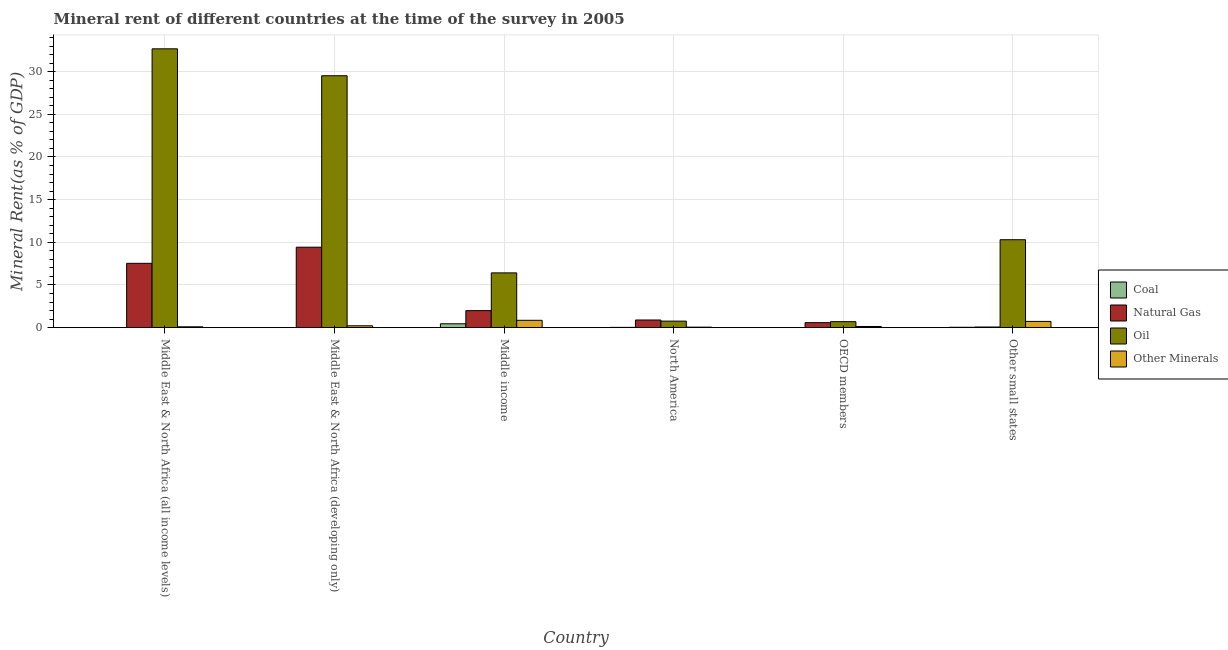How many different coloured bars are there?
Keep it short and to the point. 4. How many groups of bars are there?
Provide a succinct answer. 6. Are the number of bars per tick equal to the number of legend labels?
Offer a very short reply. Yes. Are the number of bars on each tick of the X-axis equal?
Offer a terse response. Yes. How many bars are there on the 6th tick from the left?
Provide a short and direct response. 4. What is the label of the 2nd group of bars from the left?
Provide a succinct answer. Middle East & North Africa (developing only). In how many cases, is the number of bars for a given country not equal to the number of legend labels?
Give a very brief answer. 0. What is the oil rent in Other small states?
Your response must be concise. 10.3. Across all countries, what is the maximum natural gas rent?
Your response must be concise. 9.43. Across all countries, what is the minimum coal rent?
Ensure brevity in your answer.  0. In which country was the natural gas rent maximum?
Make the answer very short. Middle East & North Africa (developing only). In which country was the natural gas rent minimum?
Give a very brief answer. Other small states. What is the total natural gas rent in the graph?
Your response must be concise. 20.53. What is the difference between the  rent of other minerals in Middle income and that in North America?
Provide a succinct answer. 0.8. What is the difference between the coal rent in Middle income and the natural gas rent in North America?
Give a very brief answer. -0.44. What is the average  rent of other minerals per country?
Your response must be concise. 0.35. What is the difference between the  rent of other minerals and coal rent in North America?
Provide a succinct answer. 0.02. What is the ratio of the oil rent in Middle income to that in Other small states?
Make the answer very short. 0.62. Is the difference between the oil rent in Middle East & North Africa (developing only) and North America greater than the difference between the  rent of other minerals in Middle East & North Africa (developing only) and North America?
Offer a terse response. Yes. What is the difference between the highest and the second highest  rent of other minerals?
Give a very brief answer. 0.13. What is the difference between the highest and the lowest natural gas rent?
Ensure brevity in your answer.  9.35. What does the 2nd bar from the left in OECD members represents?
Offer a very short reply. Natural Gas. What does the 3rd bar from the right in Middle East & North Africa (all income levels) represents?
Your answer should be compact. Natural Gas. Is it the case that in every country, the sum of the coal rent and natural gas rent is greater than the oil rent?
Provide a short and direct response. No. How many bars are there?
Ensure brevity in your answer.  24. How many countries are there in the graph?
Ensure brevity in your answer.  6. Does the graph contain any zero values?
Provide a short and direct response. No. Does the graph contain grids?
Provide a succinct answer. Yes. How many legend labels are there?
Give a very brief answer. 4. What is the title of the graph?
Offer a terse response. Mineral rent of different countries at the time of the survey in 2005. What is the label or title of the Y-axis?
Offer a very short reply. Mineral Rent(as % of GDP). What is the Mineral Rent(as % of GDP) of Coal in Middle East & North Africa (all income levels)?
Give a very brief answer. 0. What is the Mineral Rent(as % of GDP) of Natural Gas in Middle East & North Africa (all income levels)?
Your response must be concise. 7.54. What is the Mineral Rent(as % of GDP) of Oil in Middle East & North Africa (all income levels)?
Your answer should be very brief. 32.67. What is the Mineral Rent(as % of GDP) in Other Minerals in Middle East & North Africa (all income levels)?
Provide a succinct answer. 0.1. What is the Mineral Rent(as % of GDP) in Coal in Middle East & North Africa (developing only)?
Your answer should be very brief. 0.01. What is the Mineral Rent(as % of GDP) in Natural Gas in Middle East & North Africa (developing only)?
Keep it short and to the point. 9.43. What is the Mineral Rent(as % of GDP) in Oil in Middle East & North Africa (developing only)?
Ensure brevity in your answer.  29.52. What is the Mineral Rent(as % of GDP) in Other Minerals in Middle East & North Africa (developing only)?
Your answer should be compact. 0.22. What is the Mineral Rent(as % of GDP) of Coal in Middle income?
Ensure brevity in your answer.  0.46. What is the Mineral Rent(as % of GDP) in Natural Gas in Middle income?
Provide a short and direct response. 1.99. What is the Mineral Rent(as % of GDP) in Oil in Middle income?
Keep it short and to the point. 6.42. What is the Mineral Rent(as % of GDP) in Other Minerals in Middle income?
Provide a succinct answer. 0.86. What is the Mineral Rent(as % of GDP) in Coal in North America?
Your answer should be compact. 0.04. What is the Mineral Rent(as % of GDP) of Natural Gas in North America?
Ensure brevity in your answer.  0.9. What is the Mineral Rent(as % of GDP) in Oil in North America?
Offer a very short reply. 0.77. What is the Mineral Rent(as % of GDP) of Other Minerals in North America?
Ensure brevity in your answer.  0.06. What is the Mineral Rent(as % of GDP) of Coal in OECD members?
Your response must be concise. 0.02. What is the Mineral Rent(as % of GDP) in Natural Gas in OECD members?
Offer a very short reply. 0.59. What is the Mineral Rent(as % of GDP) in Oil in OECD members?
Your answer should be very brief. 0.7. What is the Mineral Rent(as % of GDP) in Other Minerals in OECD members?
Make the answer very short. 0.14. What is the Mineral Rent(as % of GDP) of Coal in Other small states?
Your answer should be very brief. 0.05. What is the Mineral Rent(as % of GDP) of Natural Gas in Other small states?
Offer a very short reply. 0.08. What is the Mineral Rent(as % of GDP) of Oil in Other small states?
Your answer should be compact. 10.3. What is the Mineral Rent(as % of GDP) of Other Minerals in Other small states?
Keep it short and to the point. 0.73. Across all countries, what is the maximum Mineral Rent(as % of GDP) of Coal?
Your answer should be very brief. 0.46. Across all countries, what is the maximum Mineral Rent(as % of GDP) in Natural Gas?
Offer a terse response. 9.43. Across all countries, what is the maximum Mineral Rent(as % of GDP) in Oil?
Offer a terse response. 32.67. Across all countries, what is the maximum Mineral Rent(as % of GDP) in Other Minerals?
Offer a terse response. 0.86. Across all countries, what is the minimum Mineral Rent(as % of GDP) of Coal?
Make the answer very short. 0. Across all countries, what is the minimum Mineral Rent(as % of GDP) in Natural Gas?
Your answer should be very brief. 0.08. Across all countries, what is the minimum Mineral Rent(as % of GDP) of Oil?
Keep it short and to the point. 0.7. Across all countries, what is the minimum Mineral Rent(as % of GDP) in Other Minerals?
Ensure brevity in your answer.  0.06. What is the total Mineral Rent(as % of GDP) in Coal in the graph?
Provide a short and direct response. 0.56. What is the total Mineral Rent(as % of GDP) in Natural Gas in the graph?
Your answer should be very brief. 20.53. What is the total Mineral Rent(as % of GDP) in Oil in the graph?
Offer a very short reply. 80.39. What is the total Mineral Rent(as % of GDP) in Other Minerals in the graph?
Offer a terse response. 2.11. What is the difference between the Mineral Rent(as % of GDP) of Coal in Middle East & North Africa (all income levels) and that in Middle East & North Africa (developing only)?
Your answer should be compact. -0. What is the difference between the Mineral Rent(as % of GDP) in Natural Gas in Middle East & North Africa (all income levels) and that in Middle East & North Africa (developing only)?
Your answer should be very brief. -1.89. What is the difference between the Mineral Rent(as % of GDP) in Oil in Middle East & North Africa (all income levels) and that in Middle East & North Africa (developing only)?
Keep it short and to the point. 3.15. What is the difference between the Mineral Rent(as % of GDP) in Other Minerals in Middle East & North Africa (all income levels) and that in Middle East & North Africa (developing only)?
Your response must be concise. -0.12. What is the difference between the Mineral Rent(as % of GDP) in Coal in Middle East & North Africa (all income levels) and that in Middle income?
Offer a terse response. -0.45. What is the difference between the Mineral Rent(as % of GDP) of Natural Gas in Middle East & North Africa (all income levels) and that in Middle income?
Your response must be concise. 5.55. What is the difference between the Mineral Rent(as % of GDP) in Oil in Middle East & North Africa (all income levels) and that in Middle income?
Your response must be concise. 26.26. What is the difference between the Mineral Rent(as % of GDP) in Other Minerals in Middle East & North Africa (all income levels) and that in Middle income?
Keep it short and to the point. -0.76. What is the difference between the Mineral Rent(as % of GDP) of Coal in Middle East & North Africa (all income levels) and that in North America?
Your answer should be very brief. -0.03. What is the difference between the Mineral Rent(as % of GDP) of Natural Gas in Middle East & North Africa (all income levels) and that in North America?
Your response must be concise. 6.64. What is the difference between the Mineral Rent(as % of GDP) of Oil in Middle East & North Africa (all income levels) and that in North America?
Your answer should be very brief. 31.91. What is the difference between the Mineral Rent(as % of GDP) in Other Minerals in Middle East & North Africa (all income levels) and that in North America?
Your answer should be very brief. 0.04. What is the difference between the Mineral Rent(as % of GDP) of Coal in Middle East & North Africa (all income levels) and that in OECD members?
Your response must be concise. -0.01. What is the difference between the Mineral Rent(as % of GDP) in Natural Gas in Middle East & North Africa (all income levels) and that in OECD members?
Offer a very short reply. 6.95. What is the difference between the Mineral Rent(as % of GDP) in Oil in Middle East & North Africa (all income levels) and that in OECD members?
Offer a terse response. 31.97. What is the difference between the Mineral Rent(as % of GDP) in Other Minerals in Middle East & North Africa (all income levels) and that in OECD members?
Your answer should be very brief. -0.03. What is the difference between the Mineral Rent(as % of GDP) in Coal in Middle East & North Africa (all income levels) and that in Other small states?
Offer a very short reply. -0.04. What is the difference between the Mineral Rent(as % of GDP) in Natural Gas in Middle East & North Africa (all income levels) and that in Other small states?
Keep it short and to the point. 7.46. What is the difference between the Mineral Rent(as % of GDP) of Oil in Middle East & North Africa (all income levels) and that in Other small states?
Ensure brevity in your answer.  22.37. What is the difference between the Mineral Rent(as % of GDP) in Other Minerals in Middle East & North Africa (all income levels) and that in Other small states?
Provide a succinct answer. -0.63. What is the difference between the Mineral Rent(as % of GDP) of Coal in Middle East & North Africa (developing only) and that in Middle income?
Your answer should be compact. -0.45. What is the difference between the Mineral Rent(as % of GDP) in Natural Gas in Middle East & North Africa (developing only) and that in Middle income?
Make the answer very short. 7.44. What is the difference between the Mineral Rent(as % of GDP) of Oil in Middle East & North Africa (developing only) and that in Middle income?
Give a very brief answer. 23.1. What is the difference between the Mineral Rent(as % of GDP) in Other Minerals in Middle East & North Africa (developing only) and that in Middle income?
Offer a very short reply. -0.64. What is the difference between the Mineral Rent(as % of GDP) in Coal in Middle East & North Africa (developing only) and that in North America?
Your response must be concise. -0.03. What is the difference between the Mineral Rent(as % of GDP) of Natural Gas in Middle East & North Africa (developing only) and that in North America?
Your response must be concise. 8.53. What is the difference between the Mineral Rent(as % of GDP) of Oil in Middle East & North Africa (developing only) and that in North America?
Your answer should be compact. 28.75. What is the difference between the Mineral Rent(as % of GDP) in Other Minerals in Middle East & North Africa (developing only) and that in North America?
Offer a terse response. 0.16. What is the difference between the Mineral Rent(as % of GDP) of Coal in Middle East & North Africa (developing only) and that in OECD members?
Offer a very short reply. -0.01. What is the difference between the Mineral Rent(as % of GDP) of Natural Gas in Middle East & North Africa (developing only) and that in OECD members?
Provide a short and direct response. 8.84. What is the difference between the Mineral Rent(as % of GDP) in Oil in Middle East & North Africa (developing only) and that in OECD members?
Offer a very short reply. 28.82. What is the difference between the Mineral Rent(as % of GDP) in Other Minerals in Middle East & North Africa (developing only) and that in OECD members?
Provide a short and direct response. 0.08. What is the difference between the Mineral Rent(as % of GDP) in Coal in Middle East & North Africa (developing only) and that in Other small states?
Your answer should be very brief. -0.04. What is the difference between the Mineral Rent(as % of GDP) in Natural Gas in Middle East & North Africa (developing only) and that in Other small states?
Give a very brief answer. 9.35. What is the difference between the Mineral Rent(as % of GDP) of Oil in Middle East & North Africa (developing only) and that in Other small states?
Offer a very short reply. 19.22. What is the difference between the Mineral Rent(as % of GDP) in Other Minerals in Middle East & North Africa (developing only) and that in Other small states?
Your answer should be very brief. -0.51. What is the difference between the Mineral Rent(as % of GDP) in Coal in Middle income and that in North America?
Your response must be concise. 0.42. What is the difference between the Mineral Rent(as % of GDP) of Natural Gas in Middle income and that in North America?
Ensure brevity in your answer.  1.1. What is the difference between the Mineral Rent(as % of GDP) of Oil in Middle income and that in North America?
Keep it short and to the point. 5.65. What is the difference between the Mineral Rent(as % of GDP) of Other Minerals in Middle income and that in North America?
Provide a short and direct response. 0.8. What is the difference between the Mineral Rent(as % of GDP) of Coal in Middle income and that in OECD members?
Provide a short and direct response. 0.44. What is the difference between the Mineral Rent(as % of GDP) of Natural Gas in Middle income and that in OECD members?
Make the answer very short. 1.41. What is the difference between the Mineral Rent(as % of GDP) in Oil in Middle income and that in OECD members?
Your answer should be very brief. 5.72. What is the difference between the Mineral Rent(as % of GDP) in Other Minerals in Middle income and that in OECD members?
Provide a succinct answer. 0.73. What is the difference between the Mineral Rent(as % of GDP) of Coal in Middle income and that in Other small states?
Ensure brevity in your answer.  0.41. What is the difference between the Mineral Rent(as % of GDP) of Natural Gas in Middle income and that in Other small states?
Provide a succinct answer. 1.92. What is the difference between the Mineral Rent(as % of GDP) in Oil in Middle income and that in Other small states?
Your answer should be very brief. -3.88. What is the difference between the Mineral Rent(as % of GDP) in Other Minerals in Middle income and that in Other small states?
Keep it short and to the point. 0.13. What is the difference between the Mineral Rent(as % of GDP) of Coal in North America and that in OECD members?
Your response must be concise. 0.02. What is the difference between the Mineral Rent(as % of GDP) of Natural Gas in North America and that in OECD members?
Offer a terse response. 0.31. What is the difference between the Mineral Rent(as % of GDP) of Oil in North America and that in OECD members?
Offer a terse response. 0.06. What is the difference between the Mineral Rent(as % of GDP) of Other Minerals in North America and that in OECD members?
Provide a succinct answer. -0.08. What is the difference between the Mineral Rent(as % of GDP) in Coal in North America and that in Other small states?
Keep it short and to the point. -0.01. What is the difference between the Mineral Rent(as % of GDP) of Natural Gas in North America and that in Other small states?
Provide a short and direct response. 0.82. What is the difference between the Mineral Rent(as % of GDP) in Oil in North America and that in Other small states?
Ensure brevity in your answer.  -9.54. What is the difference between the Mineral Rent(as % of GDP) of Other Minerals in North America and that in Other small states?
Make the answer very short. -0.67. What is the difference between the Mineral Rent(as % of GDP) of Coal in OECD members and that in Other small states?
Offer a terse response. -0.03. What is the difference between the Mineral Rent(as % of GDP) in Natural Gas in OECD members and that in Other small states?
Give a very brief answer. 0.51. What is the difference between the Mineral Rent(as % of GDP) of Oil in OECD members and that in Other small states?
Make the answer very short. -9.6. What is the difference between the Mineral Rent(as % of GDP) of Other Minerals in OECD members and that in Other small states?
Offer a terse response. -0.6. What is the difference between the Mineral Rent(as % of GDP) in Coal in Middle East & North Africa (all income levels) and the Mineral Rent(as % of GDP) in Natural Gas in Middle East & North Africa (developing only)?
Provide a succinct answer. -9.43. What is the difference between the Mineral Rent(as % of GDP) in Coal in Middle East & North Africa (all income levels) and the Mineral Rent(as % of GDP) in Oil in Middle East & North Africa (developing only)?
Offer a very short reply. -29.52. What is the difference between the Mineral Rent(as % of GDP) of Coal in Middle East & North Africa (all income levels) and the Mineral Rent(as % of GDP) of Other Minerals in Middle East & North Africa (developing only)?
Keep it short and to the point. -0.22. What is the difference between the Mineral Rent(as % of GDP) of Natural Gas in Middle East & North Africa (all income levels) and the Mineral Rent(as % of GDP) of Oil in Middle East & North Africa (developing only)?
Provide a short and direct response. -21.98. What is the difference between the Mineral Rent(as % of GDP) of Natural Gas in Middle East & North Africa (all income levels) and the Mineral Rent(as % of GDP) of Other Minerals in Middle East & North Africa (developing only)?
Make the answer very short. 7.32. What is the difference between the Mineral Rent(as % of GDP) in Oil in Middle East & North Africa (all income levels) and the Mineral Rent(as % of GDP) in Other Minerals in Middle East & North Africa (developing only)?
Give a very brief answer. 32.46. What is the difference between the Mineral Rent(as % of GDP) in Coal in Middle East & North Africa (all income levels) and the Mineral Rent(as % of GDP) in Natural Gas in Middle income?
Give a very brief answer. -1.99. What is the difference between the Mineral Rent(as % of GDP) in Coal in Middle East & North Africa (all income levels) and the Mineral Rent(as % of GDP) in Oil in Middle income?
Offer a terse response. -6.42. What is the difference between the Mineral Rent(as % of GDP) of Coal in Middle East & North Africa (all income levels) and the Mineral Rent(as % of GDP) of Other Minerals in Middle income?
Offer a very short reply. -0.86. What is the difference between the Mineral Rent(as % of GDP) of Natural Gas in Middle East & North Africa (all income levels) and the Mineral Rent(as % of GDP) of Oil in Middle income?
Give a very brief answer. 1.12. What is the difference between the Mineral Rent(as % of GDP) of Natural Gas in Middle East & North Africa (all income levels) and the Mineral Rent(as % of GDP) of Other Minerals in Middle income?
Provide a short and direct response. 6.68. What is the difference between the Mineral Rent(as % of GDP) in Oil in Middle East & North Africa (all income levels) and the Mineral Rent(as % of GDP) in Other Minerals in Middle income?
Ensure brevity in your answer.  31.81. What is the difference between the Mineral Rent(as % of GDP) of Coal in Middle East & North Africa (all income levels) and the Mineral Rent(as % of GDP) of Natural Gas in North America?
Keep it short and to the point. -0.9. What is the difference between the Mineral Rent(as % of GDP) of Coal in Middle East & North Africa (all income levels) and the Mineral Rent(as % of GDP) of Oil in North America?
Offer a terse response. -0.76. What is the difference between the Mineral Rent(as % of GDP) of Coal in Middle East & North Africa (all income levels) and the Mineral Rent(as % of GDP) of Other Minerals in North America?
Keep it short and to the point. -0.06. What is the difference between the Mineral Rent(as % of GDP) of Natural Gas in Middle East & North Africa (all income levels) and the Mineral Rent(as % of GDP) of Oil in North America?
Ensure brevity in your answer.  6.77. What is the difference between the Mineral Rent(as % of GDP) in Natural Gas in Middle East & North Africa (all income levels) and the Mineral Rent(as % of GDP) in Other Minerals in North America?
Your answer should be compact. 7.48. What is the difference between the Mineral Rent(as % of GDP) in Oil in Middle East & North Africa (all income levels) and the Mineral Rent(as % of GDP) in Other Minerals in North America?
Your answer should be compact. 32.61. What is the difference between the Mineral Rent(as % of GDP) of Coal in Middle East & North Africa (all income levels) and the Mineral Rent(as % of GDP) of Natural Gas in OECD members?
Keep it short and to the point. -0.59. What is the difference between the Mineral Rent(as % of GDP) of Coal in Middle East & North Africa (all income levels) and the Mineral Rent(as % of GDP) of Oil in OECD members?
Your answer should be very brief. -0.7. What is the difference between the Mineral Rent(as % of GDP) in Coal in Middle East & North Africa (all income levels) and the Mineral Rent(as % of GDP) in Other Minerals in OECD members?
Keep it short and to the point. -0.13. What is the difference between the Mineral Rent(as % of GDP) in Natural Gas in Middle East & North Africa (all income levels) and the Mineral Rent(as % of GDP) in Oil in OECD members?
Your response must be concise. 6.84. What is the difference between the Mineral Rent(as % of GDP) in Natural Gas in Middle East & North Africa (all income levels) and the Mineral Rent(as % of GDP) in Other Minerals in OECD members?
Provide a short and direct response. 7.4. What is the difference between the Mineral Rent(as % of GDP) of Oil in Middle East & North Africa (all income levels) and the Mineral Rent(as % of GDP) of Other Minerals in OECD members?
Provide a succinct answer. 32.54. What is the difference between the Mineral Rent(as % of GDP) of Coal in Middle East & North Africa (all income levels) and the Mineral Rent(as % of GDP) of Natural Gas in Other small states?
Offer a terse response. -0.07. What is the difference between the Mineral Rent(as % of GDP) in Coal in Middle East & North Africa (all income levels) and the Mineral Rent(as % of GDP) in Oil in Other small states?
Provide a succinct answer. -10.3. What is the difference between the Mineral Rent(as % of GDP) in Coal in Middle East & North Africa (all income levels) and the Mineral Rent(as % of GDP) in Other Minerals in Other small states?
Ensure brevity in your answer.  -0.73. What is the difference between the Mineral Rent(as % of GDP) in Natural Gas in Middle East & North Africa (all income levels) and the Mineral Rent(as % of GDP) in Oil in Other small states?
Keep it short and to the point. -2.76. What is the difference between the Mineral Rent(as % of GDP) of Natural Gas in Middle East & North Africa (all income levels) and the Mineral Rent(as % of GDP) of Other Minerals in Other small states?
Your answer should be very brief. 6.81. What is the difference between the Mineral Rent(as % of GDP) in Oil in Middle East & North Africa (all income levels) and the Mineral Rent(as % of GDP) in Other Minerals in Other small states?
Offer a terse response. 31.94. What is the difference between the Mineral Rent(as % of GDP) of Coal in Middle East & North Africa (developing only) and the Mineral Rent(as % of GDP) of Natural Gas in Middle income?
Offer a terse response. -1.99. What is the difference between the Mineral Rent(as % of GDP) in Coal in Middle East & North Africa (developing only) and the Mineral Rent(as % of GDP) in Oil in Middle income?
Offer a terse response. -6.41. What is the difference between the Mineral Rent(as % of GDP) in Coal in Middle East & North Africa (developing only) and the Mineral Rent(as % of GDP) in Other Minerals in Middle income?
Provide a short and direct response. -0.86. What is the difference between the Mineral Rent(as % of GDP) in Natural Gas in Middle East & North Africa (developing only) and the Mineral Rent(as % of GDP) in Oil in Middle income?
Ensure brevity in your answer.  3.01. What is the difference between the Mineral Rent(as % of GDP) of Natural Gas in Middle East & North Africa (developing only) and the Mineral Rent(as % of GDP) of Other Minerals in Middle income?
Your answer should be very brief. 8.57. What is the difference between the Mineral Rent(as % of GDP) in Oil in Middle East & North Africa (developing only) and the Mineral Rent(as % of GDP) in Other Minerals in Middle income?
Your answer should be compact. 28.66. What is the difference between the Mineral Rent(as % of GDP) of Coal in Middle East & North Africa (developing only) and the Mineral Rent(as % of GDP) of Natural Gas in North America?
Ensure brevity in your answer.  -0.89. What is the difference between the Mineral Rent(as % of GDP) of Coal in Middle East & North Africa (developing only) and the Mineral Rent(as % of GDP) of Oil in North America?
Your answer should be very brief. -0.76. What is the difference between the Mineral Rent(as % of GDP) of Coal in Middle East & North Africa (developing only) and the Mineral Rent(as % of GDP) of Other Minerals in North America?
Keep it short and to the point. -0.05. What is the difference between the Mineral Rent(as % of GDP) of Natural Gas in Middle East & North Africa (developing only) and the Mineral Rent(as % of GDP) of Oil in North America?
Your answer should be very brief. 8.66. What is the difference between the Mineral Rent(as % of GDP) in Natural Gas in Middle East & North Africa (developing only) and the Mineral Rent(as % of GDP) in Other Minerals in North America?
Provide a succinct answer. 9.37. What is the difference between the Mineral Rent(as % of GDP) of Oil in Middle East & North Africa (developing only) and the Mineral Rent(as % of GDP) of Other Minerals in North America?
Provide a succinct answer. 29.46. What is the difference between the Mineral Rent(as % of GDP) in Coal in Middle East & North Africa (developing only) and the Mineral Rent(as % of GDP) in Natural Gas in OECD members?
Your answer should be very brief. -0.58. What is the difference between the Mineral Rent(as % of GDP) of Coal in Middle East & North Africa (developing only) and the Mineral Rent(as % of GDP) of Oil in OECD members?
Give a very brief answer. -0.7. What is the difference between the Mineral Rent(as % of GDP) of Coal in Middle East & North Africa (developing only) and the Mineral Rent(as % of GDP) of Other Minerals in OECD members?
Give a very brief answer. -0.13. What is the difference between the Mineral Rent(as % of GDP) in Natural Gas in Middle East & North Africa (developing only) and the Mineral Rent(as % of GDP) in Oil in OECD members?
Keep it short and to the point. 8.73. What is the difference between the Mineral Rent(as % of GDP) in Natural Gas in Middle East & North Africa (developing only) and the Mineral Rent(as % of GDP) in Other Minerals in OECD members?
Provide a short and direct response. 9.29. What is the difference between the Mineral Rent(as % of GDP) in Oil in Middle East & North Africa (developing only) and the Mineral Rent(as % of GDP) in Other Minerals in OECD members?
Your answer should be very brief. 29.38. What is the difference between the Mineral Rent(as % of GDP) of Coal in Middle East & North Africa (developing only) and the Mineral Rent(as % of GDP) of Natural Gas in Other small states?
Your answer should be very brief. -0.07. What is the difference between the Mineral Rent(as % of GDP) in Coal in Middle East & North Africa (developing only) and the Mineral Rent(as % of GDP) in Oil in Other small states?
Provide a succinct answer. -10.3. What is the difference between the Mineral Rent(as % of GDP) of Coal in Middle East & North Africa (developing only) and the Mineral Rent(as % of GDP) of Other Minerals in Other small states?
Give a very brief answer. -0.73. What is the difference between the Mineral Rent(as % of GDP) in Natural Gas in Middle East & North Africa (developing only) and the Mineral Rent(as % of GDP) in Oil in Other small states?
Make the answer very short. -0.87. What is the difference between the Mineral Rent(as % of GDP) of Natural Gas in Middle East & North Africa (developing only) and the Mineral Rent(as % of GDP) of Other Minerals in Other small states?
Offer a terse response. 8.7. What is the difference between the Mineral Rent(as % of GDP) of Oil in Middle East & North Africa (developing only) and the Mineral Rent(as % of GDP) of Other Minerals in Other small states?
Provide a succinct answer. 28.79. What is the difference between the Mineral Rent(as % of GDP) of Coal in Middle income and the Mineral Rent(as % of GDP) of Natural Gas in North America?
Provide a short and direct response. -0.44. What is the difference between the Mineral Rent(as % of GDP) in Coal in Middle income and the Mineral Rent(as % of GDP) in Oil in North America?
Offer a very short reply. -0.31. What is the difference between the Mineral Rent(as % of GDP) of Coal in Middle income and the Mineral Rent(as % of GDP) of Other Minerals in North America?
Make the answer very short. 0.4. What is the difference between the Mineral Rent(as % of GDP) in Natural Gas in Middle income and the Mineral Rent(as % of GDP) in Oil in North America?
Provide a succinct answer. 1.23. What is the difference between the Mineral Rent(as % of GDP) in Natural Gas in Middle income and the Mineral Rent(as % of GDP) in Other Minerals in North America?
Your answer should be very brief. 1.93. What is the difference between the Mineral Rent(as % of GDP) of Oil in Middle income and the Mineral Rent(as % of GDP) of Other Minerals in North America?
Make the answer very short. 6.36. What is the difference between the Mineral Rent(as % of GDP) of Coal in Middle income and the Mineral Rent(as % of GDP) of Natural Gas in OECD members?
Provide a succinct answer. -0.13. What is the difference between the Mineral Rent(as % of GDP) in Coal in Middle income and the Mineral Rent(as % of GDP) in Oil in OECD members?
Provide a short and direct response. -0.25. What is the difference between the Mineral Rent(as % of GDP) in Coal in Middle income and the Mineral Rent(as % of GDP) in Other Minerals in OECD members?
Give a very brief answer. 0.32. What is the difference between the Mineral Rent(as % of GDP) in Natural Gas in Middle income and the Mineral Rent(as % of GDP) in Oil in OECD members?
Make the answer very short. 1.29. What is the difference between the Mineral Rent(as % of GDP) of Natural Gas in Middle income and the Mineral Rent(as % of GDP) of Other Minerals in OECD members?
Your answer should be very brief. 1.86. What is the difference between the Mineral Rent(as % of GDP) in Oil in Middle income and the Mineral Rent(as % of GDP) in Other Minerals in OECD members?
Provide a short and direct response. 6.28. What is the difference between the Mineral Rent(as % of GDP) in Coal in Middle income and the Mineral Rent(as % of GDP) in Natural Gas in Other small states?
Your answer should be compact. 0.38. What is the difference between the Mineral Rent(as % of GDP) in Coal in Middle income and the Mineral Rent(as % of GDP) in Oil in Other small states?
Provide a short and direct response. -9.85. What is the difference between the Mineral Rent(as % of GDP) in Coal in Middle income and the Mineral Rent(as % of GDP) in Other Minerals in Other small states?
Provide a short and direct response. -0.28. What is the difference between the Mineral Rent(as % of GDP) of Natural Gas in Middle income and the Mineral Rent(as % of GDP) of Oil in Other small states?
Offer a terse response. -8.31. What is the difference between the Mineral Rent(as % of GDP) of Natural Gas in Middle income and the Mineral Rent(as % of GDP) of Other Minerals in Other small states?
Make the answer very short. 1.26. What is the difference between the Mineral Rent(as % of GDP) in Oil in Middle income and the Mineral Rent(as % of GDP) in Other Minerals in Other small states?
Make the answer very short. 5.69. What is the difference between the Mineral Rent(as % of GDP) in Coal in North America and the Mineral Rent(as % of GDP) in Natural Gas in OECD members?
Your answer should be very brief. -0.55. What is the difference between the Mineral Rent(as % of GDP) of Coal in North America and the Mineral Rent(as % of GDP) of Oil in OECD members?
Provide a short and direct response. -0.67. What is the difference between the Mineral Rent(as % of GDP) of Coal in North America and the Mineral Rent(as % of GDP) of Other Minerals in OECD members?
Your answer should be very brief. -0.1. What is the difference between the Mineral Rent(as % of GDP) of Natural Gas in North America and the Mineral Rent(as % of GDP) of Oil in OECD members?
Provide a short and direct response. 0.2. What is the difference between the Mineral Rent(as % of GDP) in Natural Gas in North America and the Mineral Rent(as % of GDP) in Other Minerals in OECD members?
Ensure brevity in your answer.  0.76. What is the difference between the Mineral Rent(as % of GDP) of Oil in North America and the Mineral Rent(as % of GDP) of Other Minerals in OECD members?
Provide a succinct answer. 0.63. What is the difference between the Mineral Rent(as % of GDP) of Coal in North America and the Mineral Rent(as % of GDP) of Natural Gas in Other small states?
Give a very brief answer. -0.04. What is the difference between the Mineral Rent(as % of GDP) in Coal in North America and the Mineral Rent(as % of GDP) in Oil in Other small states?
Your response must be concise. -10.27. What is the difference between the Mineral Rent(as % of GDP) in Coal in North America and the Mineral Rent(as % of GDP) in Other Minerals in Other small states?
Keep it short and to the point. -0.7. What is the difference between the Mineral Rent(as % of GDP) of Natural Gas in North America and the Mineral Rent(as % of GDP) of Oil in Other small states?
Keep it short and to the point. -9.41. What is the difference between the Mineral Rent(as % of GDP) of Natural Gas in North America and the Mineral Rent(as % of GDP) of Other Minerals in Other small states?
Your answer should be compact. 0.17. What is the difference between the Mineral Rent(as % of GDP) in Oil in North America and the Mineral Rent(as % of GDP) in Other Minerals in Other small states?
Ensure brevity in your answer.  0.04. What is the difference between the Mineral Rent(as % of GDP) of Coal in OECD members and the Mineral Rent(as % of GDP) of Natural Gas in Other small states?
Offer a very short reply. -0.06. What is the difference between the Mineral Rent(as % of GDP) of Coal in OECD members and the Mineral Rent(as % of GDP) of Oil in Other small states?
Your answer should be compact. -10.29. What is the difference between the Mineral Rent(as % of GDP) of Coal in OECD members and the Mineral Rent(as % of GDP) of Other Minerals in Other small states?
Ensure brevity in your answer.  -0.71. What is the difference between the Mineral Rent(as % of GDP) in Natural Gas in OECD members and the Mineral Rent(as % of GDP) in Oil in Other small states?
Provide a succinct answer. -9.72. What is the difference between the Mineral Rent(as % of GDP) of Natural Gas in OECD members and the Mineral Rent(as % of GDP) of Other Minerals in Other small states?
Your response must be concise. -0.14. What is the difference between the Mineral Rent(as % of GDP) of Oil in OECD members and the Mineral Rent(as % of GDP) of Other Minerals in Other small states?
Make the answer very short. -0.03. What is the average Mineral Rent(as % of GDP) of Coal per country?
Keep it short and to the point. 0.09. What is the average Mineral Rent(as % of GDP) of Natural Gas per country?
Provide a short and direct response. 3.42. What is the average Mineral Rent(as % of GDP) in Oil per country?
Provide a short and direct response. 13.4. What is the average Mineral Rent(as % of GDP) in Other Minerals per country?
Offer a terse response. 0.35. What is the difference between the Mineral Rent(as % of GDP) in Coal and Mineral Rent(as % of GDP) in Natural Gas in Middle East & North Africa (all income levels)?
Your response must be concise. -7.54. What is the difference between the Mineral Rent(as % of GDP) in Coal and Mineral Rent(as % of GDP) in Oil in Middle East & North Africa (all income levels)?
Your response must be concise. -32.67. What is the difference between the Mineral Rent(as % of GDP) of Coal and Mineral Rent(as % of GDP) of Other Minerals in Middle East & North Africa (all income levels)?
Make the answer very short. -0.1. What is the difference between the Mineral Rent(as % of GDP) in Natural Gas and Mineral Rent(as % of GDP) in Oil in Middle East & North Africa (all income levels)?
Make the answer very short. -25.13. What is the difference between the Mineral Rent(as % of GDP) in Natural Gas and Mineral Rent(as % of GDP) in Other Minerals in Middle East & North Africa (all income levels)?
Provide a succinct answer. 7.44. What is the difference between the Mineral Rent(as % of GDP) of Oil and Mineral Rent(as % of GDP) of Other Minerals in Middle East & North Africa (all income levels)?
Provide a succinct answer. 32.57. What is the difference between the Mineral Rent(as % of GDP) in Coal and Mineral Rent(as % of GDP) in Natural Gas in Middle East & North Africa (developing only)?
Make the answer very short. -9.42. What is the difference between the Mineral Rent(as % of GDP) of Coal and Mineral Rent(as % of GDP) of Oil in Middle East & North Africa (developing only)?
Your answer should be very brief. -29.51. What is the difference between the Mineral Rent(as % of GDP) in Coal and Mineral Rent(as % of GDP) in Other Minerals in Middle East & North Africa (developing only)?
Offer a terse response. -0.21. What is the difference between the Mineral Rent(as % of GDP) of Natural Gas and Mineral Rent(as % of GDP) of Oil in Middle East & North Africa (developing only)?
Offer a very short reply. -20.09. What is the difference between the Mineral Rent(as % of GDP) of Natural Gas and Mineral Rent(as % of GDP) of Other Minerals in Middle East & North Africa (developing only)?
Provide a short and direct response. 9.21. What is the difference between the Mineral Rent(as % of GDP) in Oil and Mineral Rent(as % of GDP) in Other Minerals in Middle East & North Africa (developing only)?
Your answer should be compact. 29.3. What is the difference between the Mineral Rent(as % of GDP) of Coal and Mineral Rent(as % of GDP) of Natural Gas in Middle income?
Make the answer very short. -1.54. What is the difference between the Mineral Rent(as % of GDP) of Coal and Mineral Rent(as % of GDP) of Oil in Middle income?
Provide a succinct answer. -5.96. What is the difference between the Mineral Rent(as % of GDP) in Coal and Mineral Rent(as % of GDP) in Other Minerals in Middle income?
Make the answer very short. -0.41. What is the difference between the Mineral Rent(as % of GDP) of Natural Gas and Mineral Rent(as % of GDP) of Oil in Middle income?
Give a very brief answer. -4.42. What is the difference between the Mineral Rent(as % of GDP) in Natural Gas and Mineral Rent(as % of GDP) in Other Minerals in Middle income?
Provide a succinct answer. 1.13. What is the difference between the Mineral Rent(as % of GDP) in Oil and Mineral Rent(as % of GDP) in Other Minerals in Middle income?
Offer a very short reply. 5.56. What is the difference between the Mineral Rent(as % of GDP) of Coal and Mineral Rent(as % of GDP) of Natural Gas in North America?
Provide a short and direct response. -0.86. What is the difference between the Mineral Rent(as % of GDP) of Coal and Mineral Rent(as % of GDP) of Oil in North America?
Provide a succinct answer. -0.73. What is the difference between the Mineral Rent(as % of GDP) of Coal and Mineral Rent(as % of GDP) of Other Minerals in North America?
Give a very brief answer. -0.02. What is the difference between the Mineral Rent(as % of GDP) in Natural Gas and Mineral Rent(as % of GDP) in Oil in North America?
Provide a succinct answer. 0.13. What is the difference between the Mineral Rent(as % of GDP) in Natural Gas and Mineral Rent(as % of GDP) in Other Minerals in North America?
Give a very brief answer. 0.84. What is the difference between the Mineral Rent(as % of GDP) of Oil and Mineral Rent(as % of GDP) of Other Minerals in North America?
Your response must be concise. 0.71. What is the difference between the Mineral Rent(as % of GDP) in Coal and Mineral Rent(as % of GDP) in Natural Gas in OECD members?
Offer a very short reply. -0.57. What is the difference between the Mineral Rent(as % of GDP) in Coal and Mineral Rent(as % of GDP) in Oil in OECD members?
Provide a succinct answer. -0.69. What is the difference between the Mineral Rent(as % of GDP) in Coal and Mineral Rent(as % of GDP) in Other Minerals in OECD members?
Give a very brief answer. -0.12. What is the difference between the Mineral Rent(as % of GDP) of Natural Gas and Mineral Rent(as % of GDP) of Oil in OECD members?
Ensure brevity in your answer.  -0.12. What is the difference between the Mineral Rent(as % of GDP) in Natural Gas and Mineral Rent(as % of GDP) in Other Minerals in OECD members?
Give a very brief answer. 0.45. What is the difference between the Mineral Rent(as % of GDP) of Oil and Mineral Rent(as % of GDP) of Other Minerals in OECD members?
Ensure brevity in your answer.  0.57. What is the difference between the Mineral Rent(as % of GDP) of Coal and Mineral Rent(as % of GDP) of Natural Gas in Other small states?
Your answer should be very brief. -0.03. What is the difference between the Mineral Rent(as % of GDP) in Coal and Mineral Rent(as % of GDP) in Oil in Other small states?
Provide a succinct answer. -10.26. What is the difference between the Mineral Rent(as % of GDP) in Coal and Mineral Rent(as % of GDP) in Other Minerals in Other small states?
Your answer should be very brief. -0.69. What is the difference between the Mineral Rent(as % of GDP) in Natural Gas and Mineral Rent(as % of GDP) in Oil in Other small states?
Your answer should be very brief. -10.23. What is the difference between the Mineral Rent(as % of GDP) in Natural Gas and Mineral Rent(as % of GDP) in Other Minerals in Other small states?
Offer a terse response. -0.65. What is the difference between the Mineral Rent(as % of GDP) in Oil and Mineral Rent(as % of GDP) in Other Minerals in Other small states?
Your answer should be compact. 9.57. What is the ratio of the Mineral Rent(as % of GDP) of Coal in Middle East & North Africa (all income levels) to that in Middle East & North Africa (developing only)?
Keep it short and to the point. 0.45. What is the ratio of the Mineral Rent(as % of GDP) in Natural Gas in Middle East & North Africa (all income levels) to that in Middle East & North Africa (developing only)?
Give a very brief answer. 0.8. What is the ratio of the Mineral Rent(as % of GDP) of Oil in Middle East & North Africa (all income levels) to that in Middle East & North Africa (developing only)?
Your answer should be compact. 1.11. What is the ratio of the Mineral Rent(as % of GDP) of Other Minerals in Middle East & North Africa (all income levels) to that in Middle East & North Africa (developing only)?
Offer a terse response. 0.46. What is the ratio of the Mineral Rent(as % of GDP) in Coal in Middle East & North Africa (all income levels) to that in Middle income?
Give a very brief answer. 0.01. What is the ratio of the Mineral Rent(as % of GDP) in Natural Gas in Middle East & North Africa (all income levels) to that in Middle income?
Offer a very short reply. 3.78. What is the ratio of the Mineral Rent(as % of GDP) of Oil in Middle East & North Africa (all income levels) to that in Middle income?
Your answer should be very brief. 5.09. What is the ratio of the Mineral Rent(as % of GDP) in Other Minerals in Middle East & North Africa (all income levels) to that in Middle income?
Your answer should be compact. 0.12. What is the ratio of the Mineral Rent(as % of GDP) of Coal in Middle East & North Africa (all income levels) to that in North America?
Your response must be concise. 0.08. What is the ratio of the Mineral Rent(as % of GDP) in Natural Gas in Middle East & North Africa (all income levels) to that in North America?
Offer a very short reply. 8.39. What is the ratio of the Mineral Rent(as % of GDP) in Oil in Middle East & North Africa (all income levels) to that in North America?
Provide a short and direct response. 42.62. What is the ratio of the Mineral Rent(as % of GDP) in Other Minerals in Middle East & North Africa (all income levels) to that in North America?
Your response must be concise. 1.69. What is the ratio of the Mineral Rent(as % of GDP) in Coal in Middle East & North Africa (all income levels) to that in OECD members?
Your answer should be compact. 0.16. What is the ratio of the Mineral Rent(as % of GDP) of Natural Gas in Middle East & North Africa (all income levels) to that in OECD members?
Your answer should be very brief. 12.82. What is the ratio of the Mineral Rent(as % of GDP) in Oil in Middle East & North Africa (all income levels) to that in OECD members?
Keep it short and to the point. 46.43. What is the ratio of the Mineral Rent(as % of GDP) in Other Minerals in Middle East & North Africa (all income levels) to that in OECD members?
Offer a terse response. 0.75. What is the ratio of the Mineral Rent(as % of GDP) in Coal in Middle East & North Africa (all income levels) to that in Other small states?
Offer a terse response. 0.06. What is the ratio of the Mineral Rent(as % of GDP) of Natural Gas in Middle East & North Africa (all income levels) to that in Other small states?
Ensure brevity in your answer.  97.27. What is the ratio of the Mineral Rent(as % of GDP) in Oil in Middle East & North Africa (all income levels) to that in Other small states?
Keep it short and to the point. 3.17. What is the ratio of the Mineral Rent(as % of GDP) of Other Minerals in Middle East & North Africa (all income levels) to that in Other small states?
Your response must be concise. 0.14. What is the ratio of the Mineral Rent(as % of GDP) of Coal in Middle East & North Africa (developing only) to that in Middle income?
Keep it short and to the point. 0.01. What is the ratio of the Mineral Rent(as % of GDP) of Natural Gas in Middle East & North Africa (developing only) to that in Middle income?
Offer a very short reply. 4.73. What is the ratio of the Mineral Rent(as % of GDP) in Oil in Middle East & North Africa (developing only) to that in Middle income?
Ensure brevity in your answer.  4.6. What is the ratio of the Mineral Rent(as % of GDP) in Other Minerals in Middle East & North Africa (developing only) to that in Middle income?
Ensure brevity in your answer.  0.25. What is the ratio of the Mineral Rent(as % of GDP) of Coal in Middle East & North Africa (developing only) to that in North America?
Your response must be concise. 0.17. What is the ratio of the Mineral Rent(as % of GDP) of Natural Gas in Middle East & North Africa (developing only) to that in North America?
Your response must be concise. 10.49. What is the ratio of the Mineral Rent(as % of GDP) of Oil in Middle East & North Africa (developing only) to that in North America?
Provide a short and direct response. 38.51. What is the ratio of the Mineral Rent(as % of GDP) of Other Minerals in Middle East & North Africa (developing only) to that in North America?
Your answer should be very brief. 3.65. What is the ratio of the Mineral Rent(as % of GDP) of Coal in Middle East & North Africa (developing only) to that in OECD members?
Your answer should be compact. 0.34. What is the ratio of the Mineral Rent(as % of GDP) of Natural Gas in Middle East & North Africa (developing only) to that in OECD members?
Keep it short and to the point. 16.03. What is the ratio of the Mineral Rent(as % of GDP) of Oil in Middle East & North Africa (developing only) to that in OECD members?
Offer a very short reply. 41.95. What is the ratio of the Mineral Rent(as % of GDP) of Other Minerals in Middle East & North Africa (developing only) to that in OECD members?
Provide a succinct answer. 1.61. What is the ratio of the Mineral Rent(as % of GDP) of Coal in Middle East & North Africa (developing only) to that in Other small states?
Provide a succinct answer. 0.13. What is the ratio of the Mineral Rent(as % of GDP) of Natural Gas in Middle East & North Africa (developing only) to that in Other small states?
Provide a short and direct response. 121.64. What is the ratio of the Mineral Rent(as % of GDP) in Oil in Middle East & North Africa (developing only) to that in Other small states?
Give a very brief answer. 2.87. What is the ratio of the Mineral Rent(as % of GDP) in Other Minerals in Middle East & North Africa (developing only) to that in Other small states?
Your answer should be compact. 0.3. What is the ratio of the Mineral Rent(as % of GDP) of Coal in Middle income to that in North America?
Your answer should be compact. 12.82. What is the ratio of the Mineral Rent(as % of GDP) of Natural Gas in Middle income to that in North America?
Provide a short and direct response. 2.22. What is the ratio of the Mineral Rent(as % of GDP) in Oil in Middle income to that in North America?
Your answer should be very brief. 8.37. What is the ratio of the Mineral Rent(as % of GDP) of Other Minerals in Middle income to that in North America?
Give a very brief answer. 14.33. What is the ratio of the Mineral Rent(as % of GDP) in Coal in Middle income to that in OECD members?
Offer a terse response. 25.91. What is the ratio of the Mineral Rent(as % of GDP) in Natural Gas in Middle income to that in OECD members?
Your answer should be compact. 3.39. What is the ratio of the Mineral Rent(as % of GDP) in Oil in Middle income to that in OECD members?
Offer a very short reply. 9.12. What is the ratio of the Mineral Rent(as % of GDP) in Other Minerals in Middle income to that in OECD members?
Make the answer very short. 6.32. What is the ratio of the Mineral Rent(as % of GDP) of Coal in Middle income to that in Other small states?
Offer a very short reply. 9.88. What is the ratio of the Mineral Rent(as % of GDP) of Natural Gas in Middle income to that in Other small states?
Provide a succinct answer. 25.73. What is the ratio of the Mineral Rent(as % of GDP) in Oil in Middle income to that in Other small states?
Give a very brief answer. 0.62. What is the ratio of the Mineral Rent(as % of GDP) of Other Minerals in Middle income to that in Other small states?
Offer a very short reply. 1.18. What is the ratio of the Mineral Rent(as % of GDP) of Coal in North America to that in OECD members?
Ensure brevity in your answer.  2.02. What is the ratio of the Mineral Rent(as % of GDP) in Natural Gas in North America to that in OECD members?
Offer a very short reply. 1.53. What is the ratio of the Mineral Rent(as % of GDP) in Oil in North America to that in OECD members?
Make the answer very short. 1.09. What is the ratio of the Mineral Rent(as % of GDP) in Other Minerals in North America to that in OECD members?
Your answer should be compact. 0.44. What is the ratio of the Mineral Rent(as % of GDP) of Coal in North America to that in Other small states?
Make the answer very short. 0.77. What is the ratio of the Mineral Rent(as % of GDP) in Natural Gas in North America to that in Other small states?
Offer a very short reply. 11.6. What is the ratio of the Mineral Rent(as % of GDP) in Oil in North America to that in Other small states?
Your answer should be very brief. 0.07. What is the ratio of the Mineral Rent(as % of GDP) in Other Minerals in North America to that in Other small states?
Your response must be concise. 0.08. What is the ratio of the Mineral Rent(as % of GDP) in Coal in OECD members to that in Other small states?
Keep it short and to the point. 0.38. What is the ratio of the Mineral Rent(as % of GDP) of Natural Gas in OECD members to that in Other small states?
Keep it short and to the point. 7.59. What is the ratio of the Mineral Rent(as % of GDP) in Oil in OECD members to that in Other small states?
Provide a short and direct response. 0.07. What is the ratio of the Mineral Rent(as % of GDP) in Other Minerals in OECD members to that in Other small states?
Ensure brevity in your answer.  0.19. What is the difference between the highest and the second highest Mineral Rent(as % of GDP) in Coal?
Provide a succinct answer. 0.41. What is the difference between the highest and the second highest Mineral Rent(as % of GDP) of Natural Gas?
Offer a terse response. 1.89. What is the difference between the highest and the second highest Mineral Rent(as % of GDP) in Oil?
Your response must be concise. 3.15. What is the difference between the highest and the second highest Mineral Rent(as % of GDP) in Other Minerals?
Offer a very short reply. 0.13. What is the difference between the highest and the lowest Mineral Rent(as % of GDP) in Coal?
Offer a terse response. 0.45. What is the difference between the highest and the lowest Mineral Rent(as % of GDP) of Natural Gas?
Give a very brief answer. 9.35. What is the difference between the highest and the lowest Mineral Rent(as % of GDP) in Oil?
Give a very brief answer. 31.97. What is the difference between the highest and the lowest Mineral Rent(as % of GDP) in Other Minerals?
Make the answer very short. 0.8. 